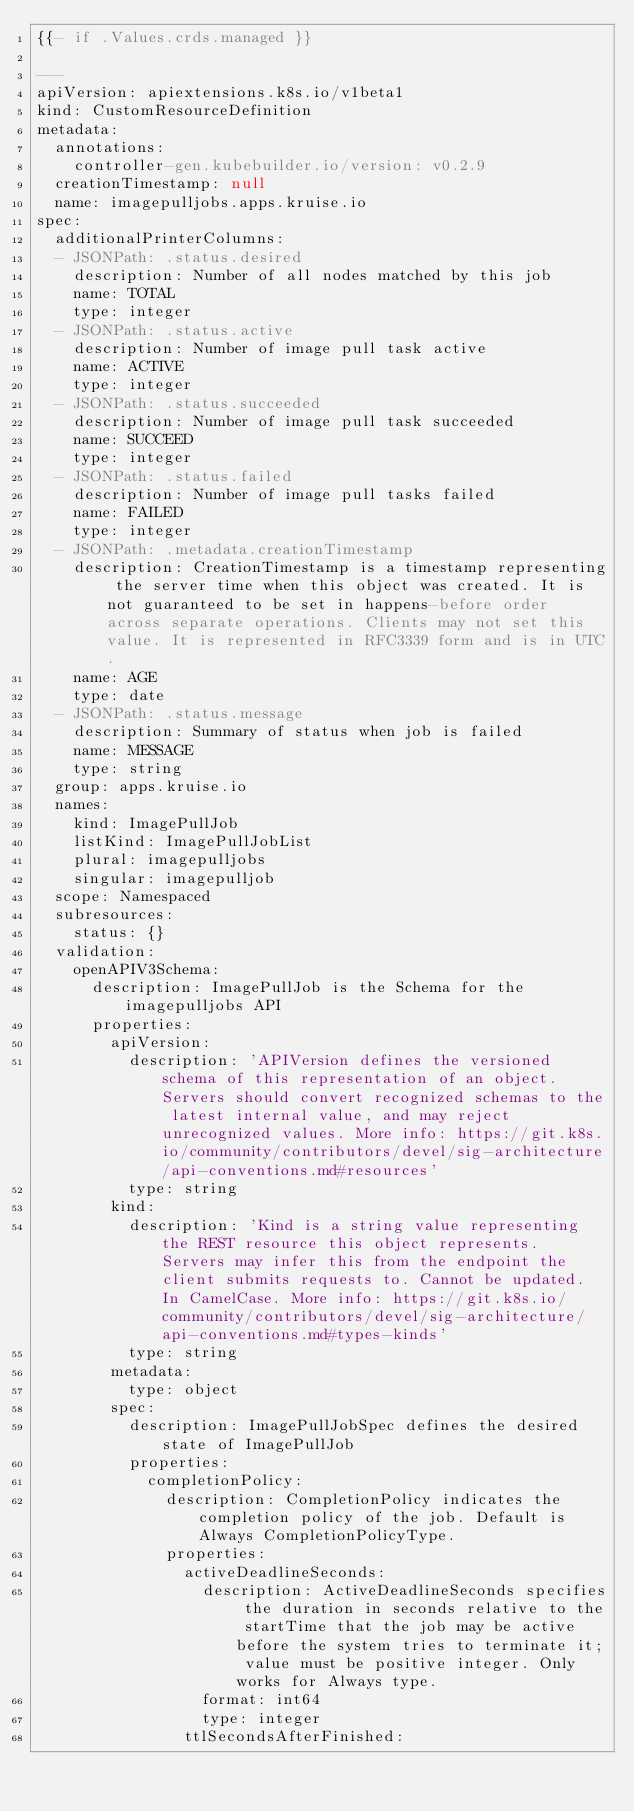Convert code to text. <code><loc_0><loc_0><loc_500><loc_500><_YAML_>{{- if .Values.crds.managed }}

---
apiVersion: apiextensions.k8s.io/v1beta1
kind: CustomResourceDefinition
metadata:
  annotations:
    controller-gen.kubebuilder.io/version: v0.2.9
  creationTimestamp: null
  name: imagepulljobs.apps.kruise.io
spec:
  additionalPrinterColumns:
  - JSONPath: .status.desired
    description: Number of all nodes matched by this job
    name: TOTAL
    type: integer
  - JSONPath: .status.active
    description: Number of image pull task active
    name: ACTIVE
    type: integer
  - JSONPath: .status.succeeded
    description: Number of image pull task succeeded
    name: SUCCEED
    type: integer
  - JSONPath: .status.failed
    description: Number of image pull tasks failed
    name: FAILED
    type: integer
  - JSONPath: .metadata.creationTimestamp
    description: CreationTimestamp is a timestamp representing the server time when this object was created. It is not guaranteed to be set in happens-before order across separate operations. Clients may not set this value. It is represented in RFC3339 form and is in UTC.
    name: AGE
    type: date
  - JSONPath: .status.message
    description: Summary of status when job is failed
    name: MESSAGE
    type: string
  group: apps.kruise.io
  names:
    kind: ImagePullJob
    listKind: ImagePullJobList
    plural: imagepulljobs
    singular: imagepulljob
  scope: Namespaced
  subresources:
    status: {}
  validation:
    openAPIV3Schema:
      description: ImagePullJob is the Schema for the imagepulljobs API
      properties:
        apiVersion:
          description: 'APIVersion defines the versioned schema of this representation of an object. Servers should convert recognized schemas to the latest internal value, and may reject unrecognized values. More info: https://git.k8s.io/community/contributors/devel/sig-architecture/api-conventions.md#resources'
          type: string
        kind:
          description: 'Kind is a string value representing the REST resource this object represents. Servers may infer this from the endpoint the client submits requests to. Cannot be updated. In CamelCase. More info: https://git.k8s.io/community/contributors/devel/sig-architecture/api-conventions.md#types-kinds'
          type: string
        metadata:
          type: object
        spec:
          description: ImagePullJobSpec defines the desired state of ImagePullJob
          properties:
            completionPolicy:
              description: CompletionPolicy indicates the completion policy of the job. Default is Always CompletionPolicyType.
              properties:
                activeDeadlineSeconds:
                  description: ActiveDeadlineSeconds specifies the duration in seconds relative to the startTime that the job may be active before the system tries to terminate it; value must be positive integer. Only works for Always type.
                  format: int64
                  type: integer
                ttlSecondsAfterFinished:</code> 